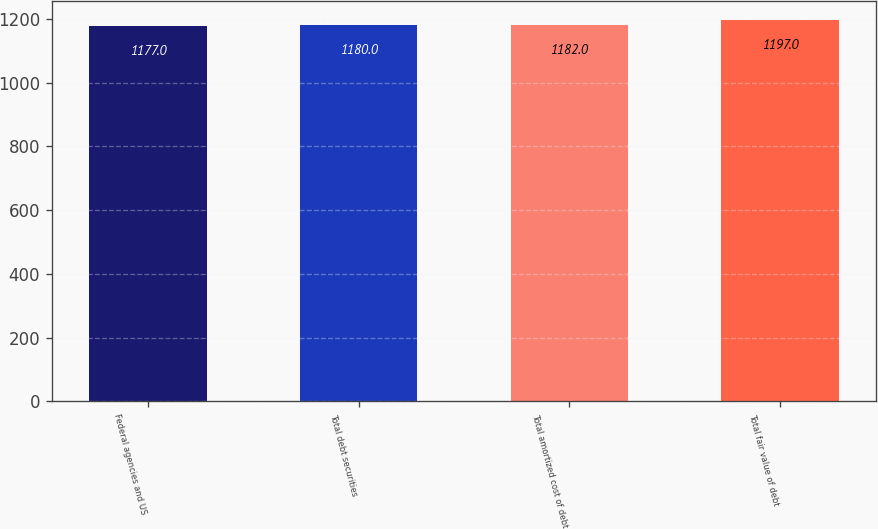Convert chart. <chart><loc_0><loc_0><loc_500><loc_500><bar_chart><fcel>Federal agencies and US<fcel>Total debt securities<fcel>Total amortized cost of debt<fcel>Total fair value of debt<nl><fcel>1177<fcel>1180<fcel>1182<fcel>1197<nl></chart> 